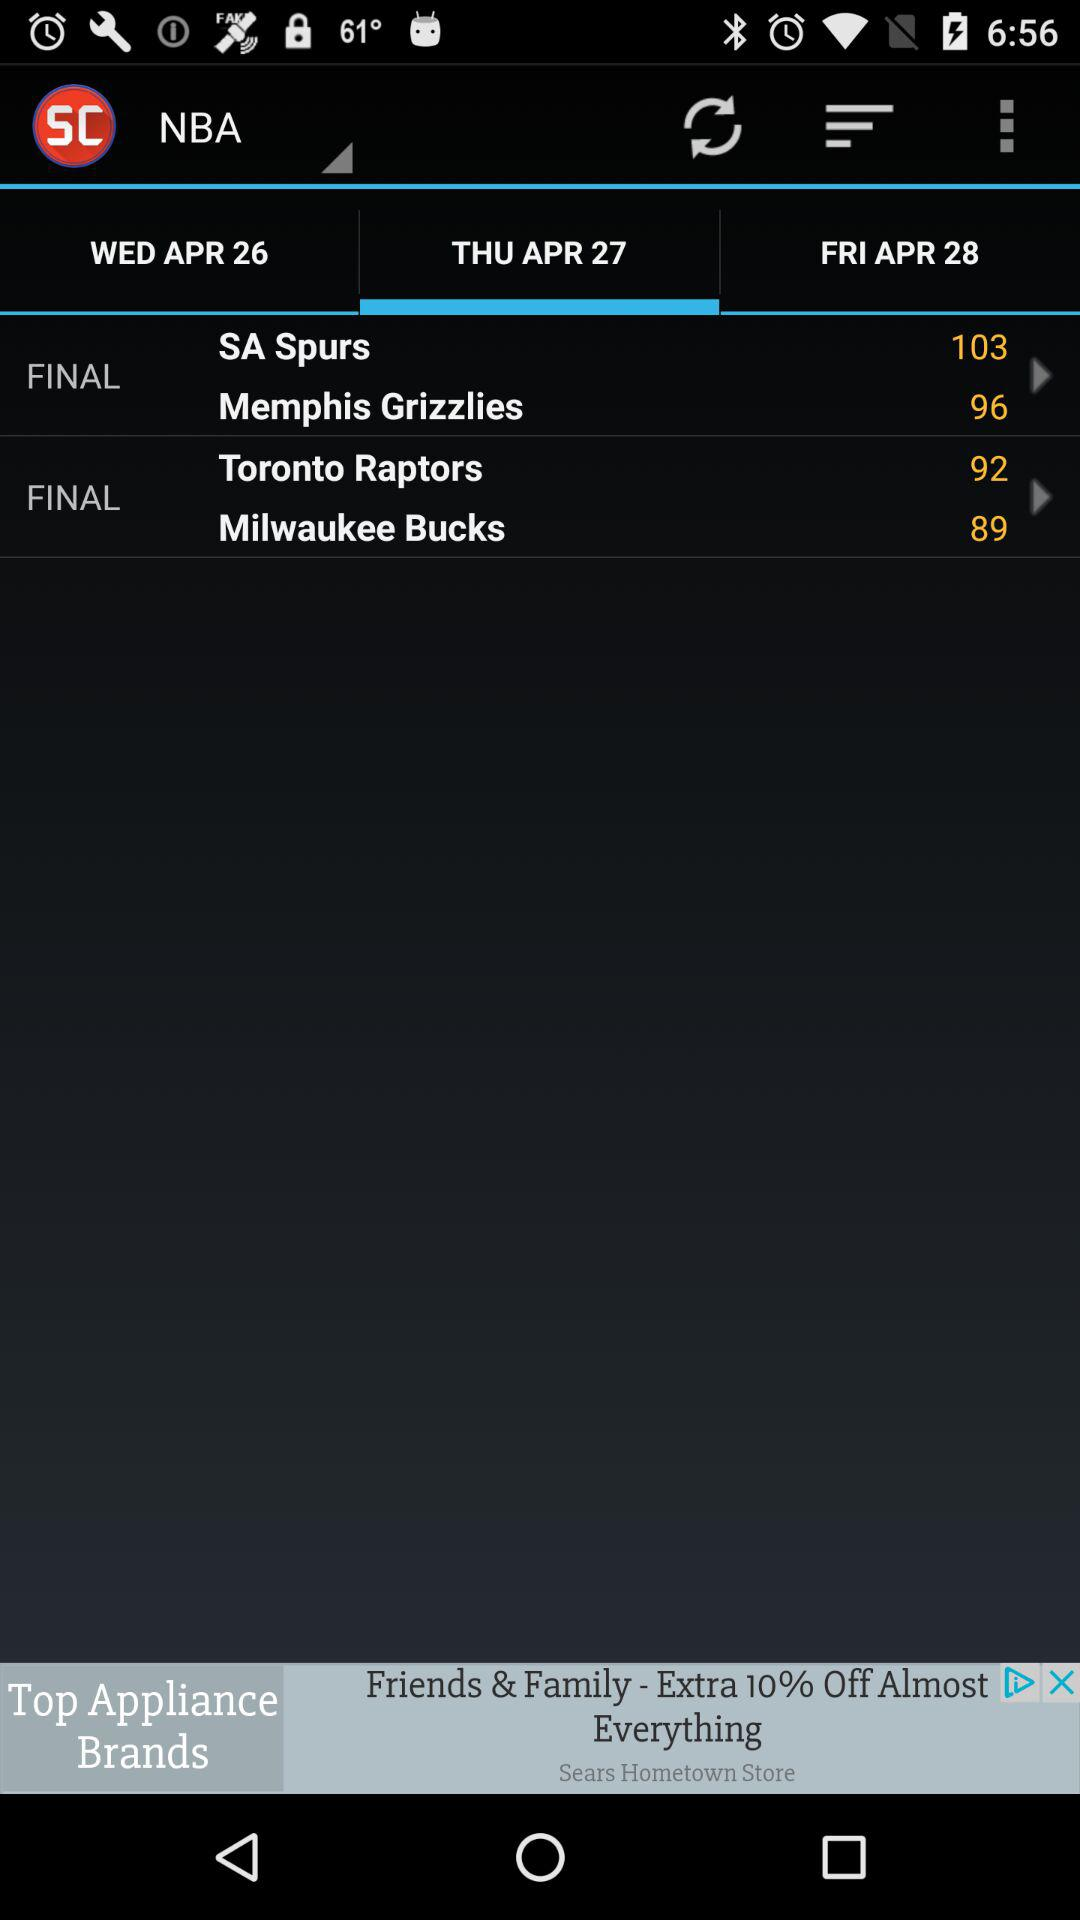The "Toronto Raptors" have how many points? The "Toronto Raptors" have 92 points. 